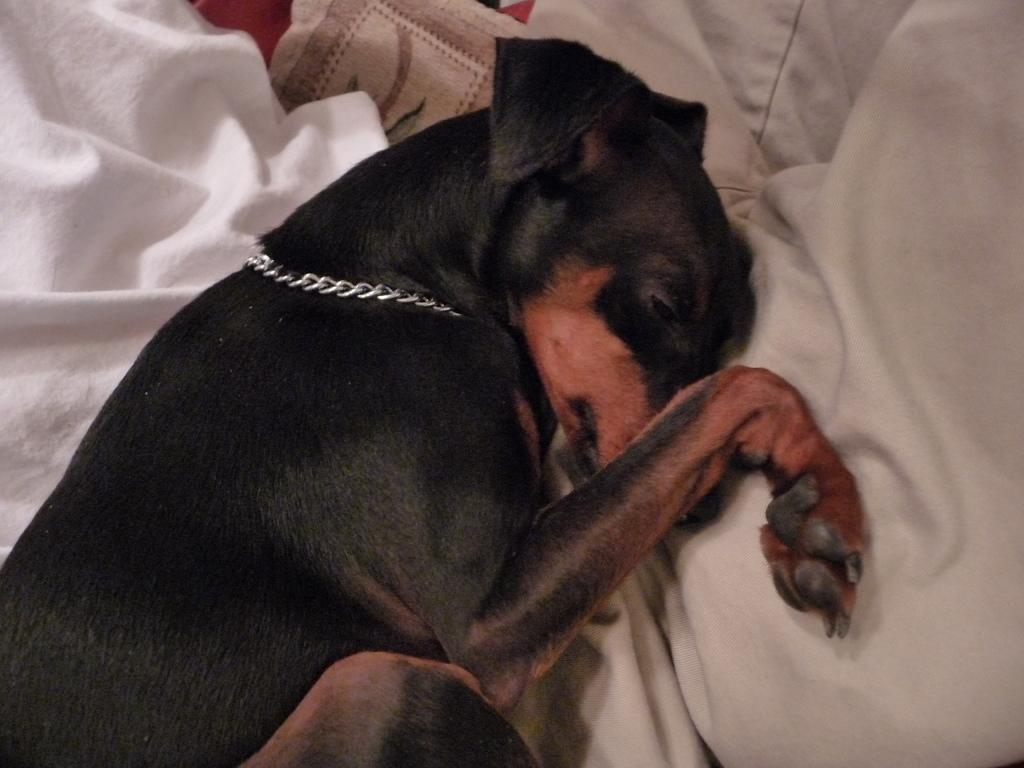What type of animal can be seen in the image? There is a dog in the image. What is the dog doing in the image? The dog is sleeping in the center of the image. What can be seen in the background of the image? There are blankets in the background of the image. What type of jewel can be seen around the dog's neck in the image? There is no jewel visible around the dog's neck in the image. What direction is the zephyr blowing in the image? There is no mention of a zephyr in the image, as it is a gentle wind that cannot be seen. 